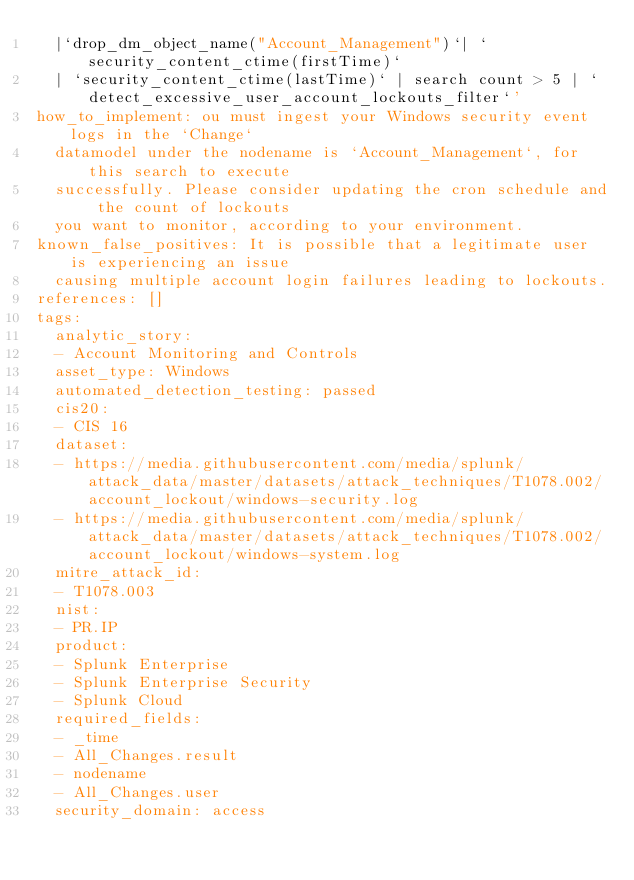Convert code to text. <code><loc_0><loc_0><loc_500><loc_500><_YAML_>  |`drop_dm_object_name("Account_Management")`| `security_content_ctime(firstTime)`
  | `security_content_ctime(lastTime)` | search count > 5 | `detect_excessive_user_account_lockouts_filter`'
how_to_implement: ou must ingest your Windows security event logs in the `Change`
  datamodel under the nodename is `Account_Management`, for this search to execute
  successfully. Please consider updating the cron schedule and the count of lockouts
  you want to monitor, according to your environment.
known_false_positives: It is possible that a legitimate user is experiencing an issue
  causing multiple account login failures leading to lockouts.
references: []
tags:
  analytic_story:
  - Account Monitoring and Controls
  asset_type: Windows
  automated_detection_testing: passed
  cis20:
  - CIS 16
  dataset:
  - https://media.githubusercontent.com/media/splunk/attack_data/master/datasets/attack_techniques/T1078.002/account_lockout/windows-security.log
  - https://media.githubusercontent.com/media/splunk/attack_data/master/datasets/attack_techniques/T1078.002/account_lockout/windows-system.log
  mitre_attack_id:
  - T1078.003
  nist:
  - PR.IP
  product:
  - Splunk Enterprise
  - Splunk Enterprise Security
  - Splunk Cloud
  required_fields:
  - _time
  - All_Changes.result
  - nodename
  - All_Changes.user
  security_domain: access
</code> 